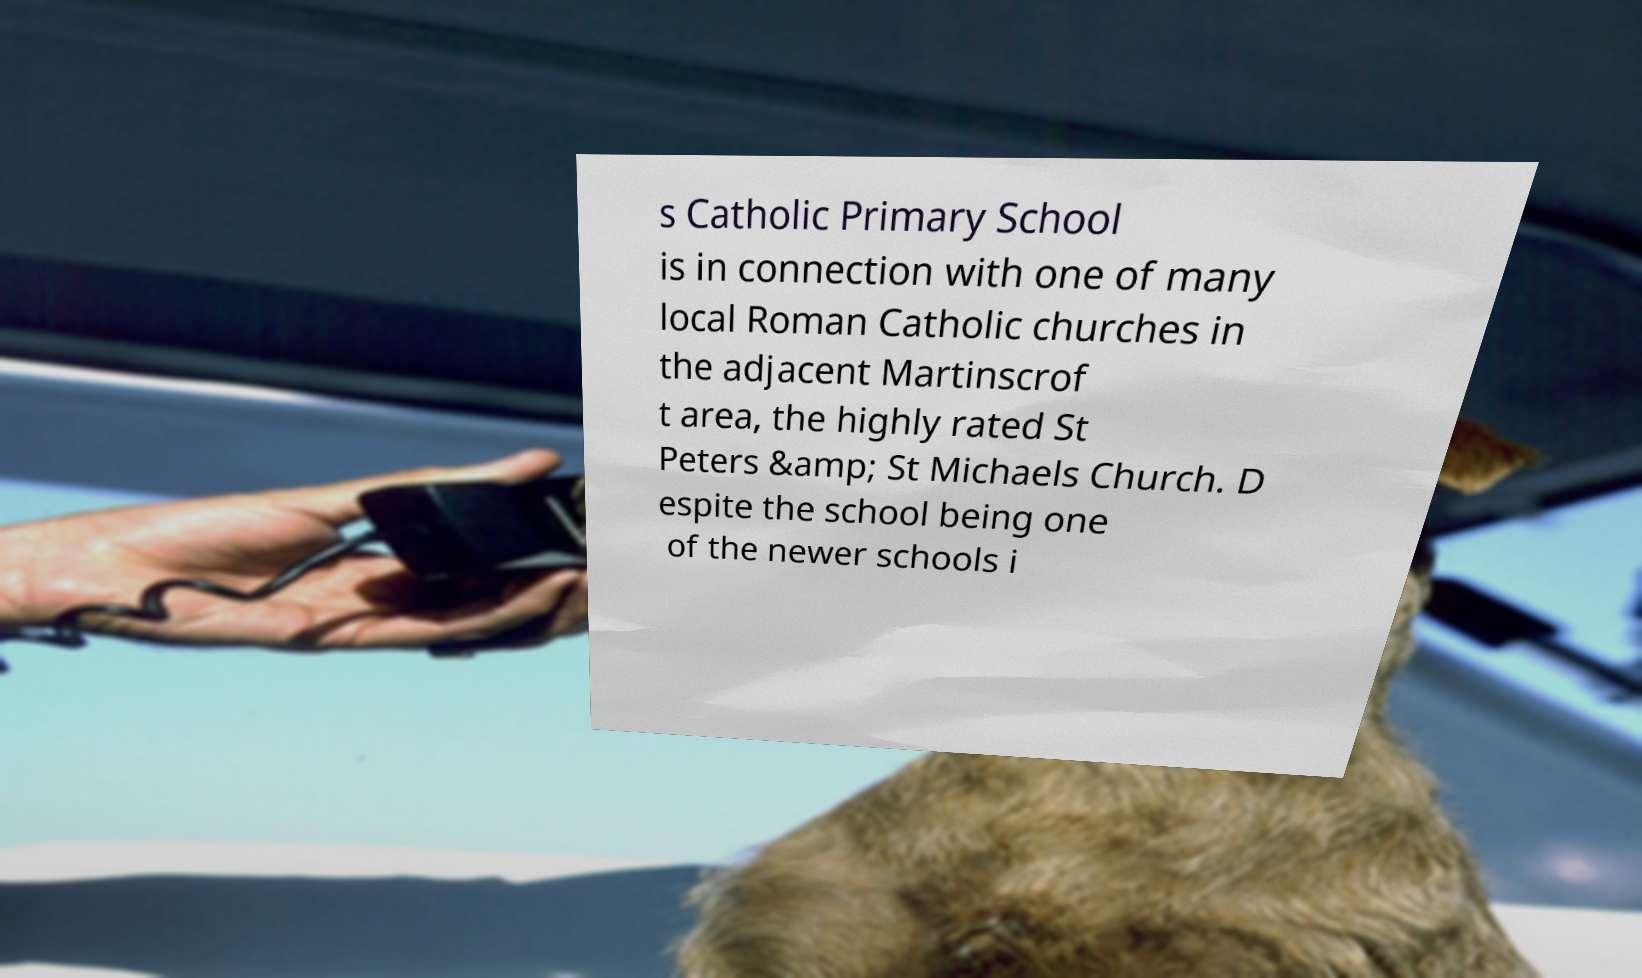Please identify and transcribe the text found in this image. s Catholic Primary School is in connection with one of many local Roman Catholic churches in the adjacent Martinscrof t area, the highly rated St Peters &amp; St Michaels Church. D espite the school being one of the newer schools i 